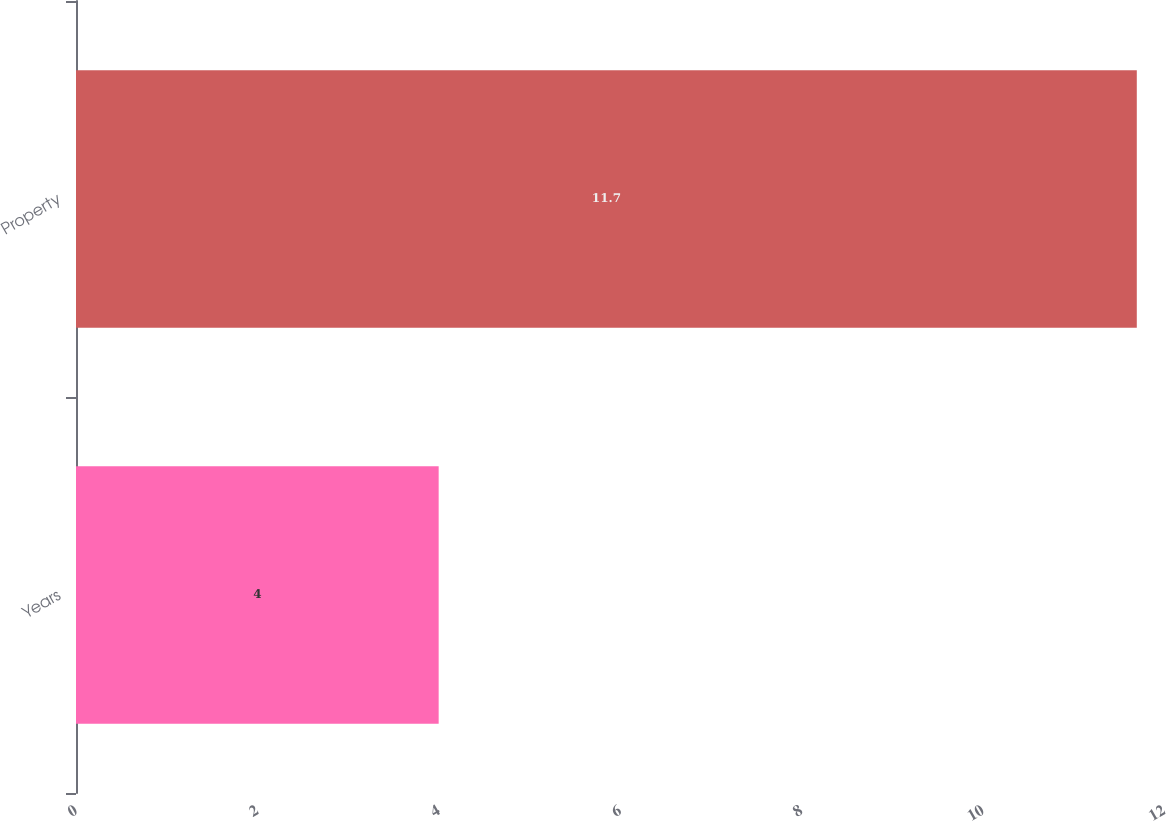Convert chart. <chart><loc_0><loc_0><loc_500><loc_500><bar_chart><fcel>Years<fcel>Property<nl><fcel>4<fcel>11.7<nl></chart> 